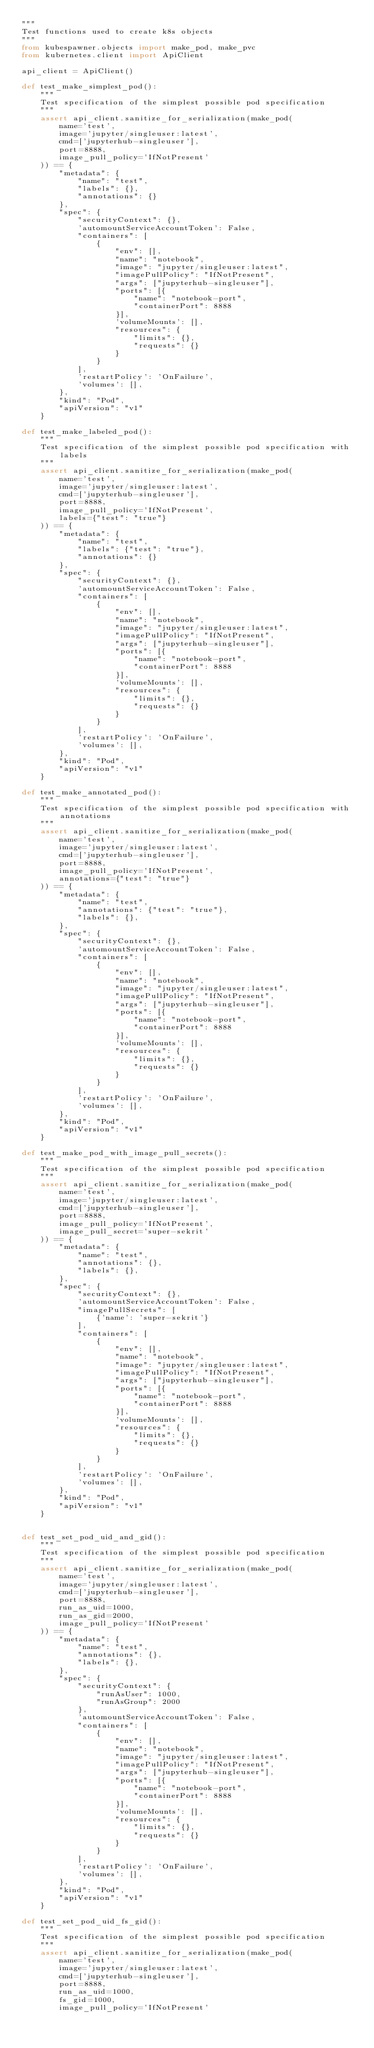<code> <loc_0><loc_0><loc_500><loc_500><_Python_>"""
Test functions used to create k8s objects
"""
from kubespawner.objects import make_pod, make_pvc
from kubernetes.client import ApiClient

api_client = ApiClient()

def test_make_simplest_pod():
    """
    Test specification of the simplest possible pod specification
    """
    assert api_client.sanitize_for_serialization(make_pod(
        name='test',
        image='jupyter/singleuser:latest',
        cmd=['jupyterhub-singleuser'],
        port=8888,
        image_pull_policy='IfNotPresent'
    )) == {
        "metadata": {
            "name": "test",
            "labels": {},
            "annotations": {}
        },
        "spec": {
            "securityContext": {},
            'automountServiceAccountToken': False,
            "containers": [
                {
                    "env": [],
                    "name": "notebook",
                    "image": "jupyter/singleuser:latest",
                    "imagePullPolicy": "IfNotPresent",
                    "args": ["jupyterhub-singleuser"],
                    "ports": [{
                        "name": "notebook-port",
                        "containerPort": 8888
                    }],
                    'volumeMounts': [],
                    "resources": {
                        "limits": {},
                        "requests": {}
                    }
                }
            ],
            'restartPolicy': 'OnFailure',
            'volumes': [],
        },
        "kind": "Pod",
        "apiVersion": "v1"
    }

def test_make_labeled_pod():
    """
    Test specification of the simplest possible pod specification with labels
    """
    assert api_client.sanitize_for_serialization(make_pod(
        name='test',
        image='jupyter/singleuser:latest',
        cmd=['jupyterhub-singleuser'],
        port=8888,
        image_pull_policy='IfNotPresent',
        labels={"test": "true"}
    )) == {
        "metadata": {
            "name": "test",
            "labels": {"test": "true"},
            "annotations": {}
        },
        "spec": {
            "securityContext": {},
            'automountServiceAccountToken': False,
            "containers": [
                {
                    "env": [],
                    "name": "notebook",
                    "image": "jupyter/singleuser:latest",
                    "imagePullPolicy": "IfNotPresent",
                    "args": ["jupyterhub-singleuser"],
                    "ports": [{
                        "name": "notebook-port",
                        "containerPort": 8888
                    }],
                    'volumeMounts': [],
                    "resources": {
                        "limits": {},
                        "requests": {}
                    }
                }
            ],
            'restartPolicy': 'OnFailure',
            'volumes': [],
        },
        "kind": "Pod",
        "apiVersion": "v1"
    }

def test_make_annotated_pod():
    """
    Test specification of the simplest possible pod specification with annotations
    """
    assert api_client.sanitize_for_serialization(make_pod(
        name='test',
        image='jupyter/singleuser:latest',
        cmd=['jupyterhub-singleuser'],
        port=8888,
        image_pull_policy='IfNotPresent',
        annotations={"test": "true"}
    )) == {
        "metadata": {
            "name": "test",
            "annotations": {"test": "true"},
            "labels": {},
        },
        "spec": {
            "securityContext": {},
            'automountServiceAccountToken': False,
            "containers": [
                {
                    "env": [],
                    "name": "notebook",
                    "image": "jupyter/singleuser:latest",
                    "imagePullPolicy": "IfNotPresent",
                    "args": ["jupyterhub-singleuser"],
                    "ports": [{
                        "name": "notebook-port",
                        "containerPort": 8888
                    }],
                    'volumeMounts': [],
                    "resources": {
                        "limits": {},
                        "requests": {}
                    }
                }
            ],
            'restartPolicy': 'OnFailure',
            'volumes': [],
        },
        "kind": "Pod",
        "apiVersion": "v1"
    }

def test_make_pod_with_image_pull_secrets():
    """
    Test specification of the simplest possible pod specification
    """
    assert api_client.sanitize_for_serialization(make_pod(
        name='test',
        image='jupyter/singleuser:latest',
        cmd=['jupyterhub-singleuser'],
        port=8888,
        image_pull_policy='IfNotPresent',
        image_pull_secret='super-sekrit'
    )) == {
        "metadata": {
            "name": "test",
            "annotations": {},
            "labels": {},
        },
        "spec": {
            "securityContext": {},
            'automountServiceAccountToken': False,
            "imagePullSecrets": [
                {'name': 'super-sekrit'}
            ],
            "containers": [
                {
                    "env": [],
                    "name": "notebook",
                    "image": "jupyter/singleuser:latest",
                    "imagePullPolicy": "IfNotPresent",
                    "args": ["jupyterhub-singleuser"],
                    "ports": [{
                        "name": "notebook-port",
                        "containerPort": 8888
                    }],
                    'volumeMounts': [],
                    "resources": {
                        "limits": {},
                        "requests": {}
                    }
                }
            ],
            'restartPolicy': 'OnFailure',
            'volumes': [],
        },
        "kind": "Pod",
        "apiVersion": "v1"
    }


def test_set_pod_uid_and_gid():
    """
    Test specification of the simplest possible pod specification
    """
    assert api_client.sanitize_for_serialization(make_pod(
        name='test',
        image='jupyter/singleuser:latest',
        cmd=['jupyterhub-singleuser'],
        port=8888,
        run_as_uid=1000,
        run_as_gid=2000,
        image_pull_policy='IfNotPresent'
    )) == {
        "metadata": {
            "name": "test",
            "annotations": {},
            "labels": {},
        },
        "spec": {
            "securityContext": {
                "runAsUser": 1000,
                "runAsGroup": 2000
            },
            'automountServiceAccountToken': False,
            "containers": [
                {
                    "env": [],
                    "name": "notebook",
                    "image": "jupyter/singleuser:latest",
                    "imagePullPolicy": "IfNotPresent",
                    "args": ["jupyterhub-singleuser"],
                    "ports": [{
                        "name": "notebook-port",
                        "containerPort": 8888
                    }],
                    'volumeMounts': [],
                    "resources": {
                        "limits": {},
                        "requests": {}
                    }
                }
            ],
            'restartPolicy': 'OnFailure',
            'volumes': [],
        },
        "kind": "Pod",
        "apiVersion": "v1"
    }

def test_set_pod_uid_fs_gid():
    """
    Test specification of the simplest possible pod specification
    """
    assert api_client.sanitize_for_serialization(make_pod(
        name='test',
        image='jupyter/singleuser:latest',
        cmd=['jupyterhub-singleuser'],
        port=8888,
        run_as_uid=1000,
        fs_gid=1000,
        image_pull_policy='IfNotPresent'</code> 